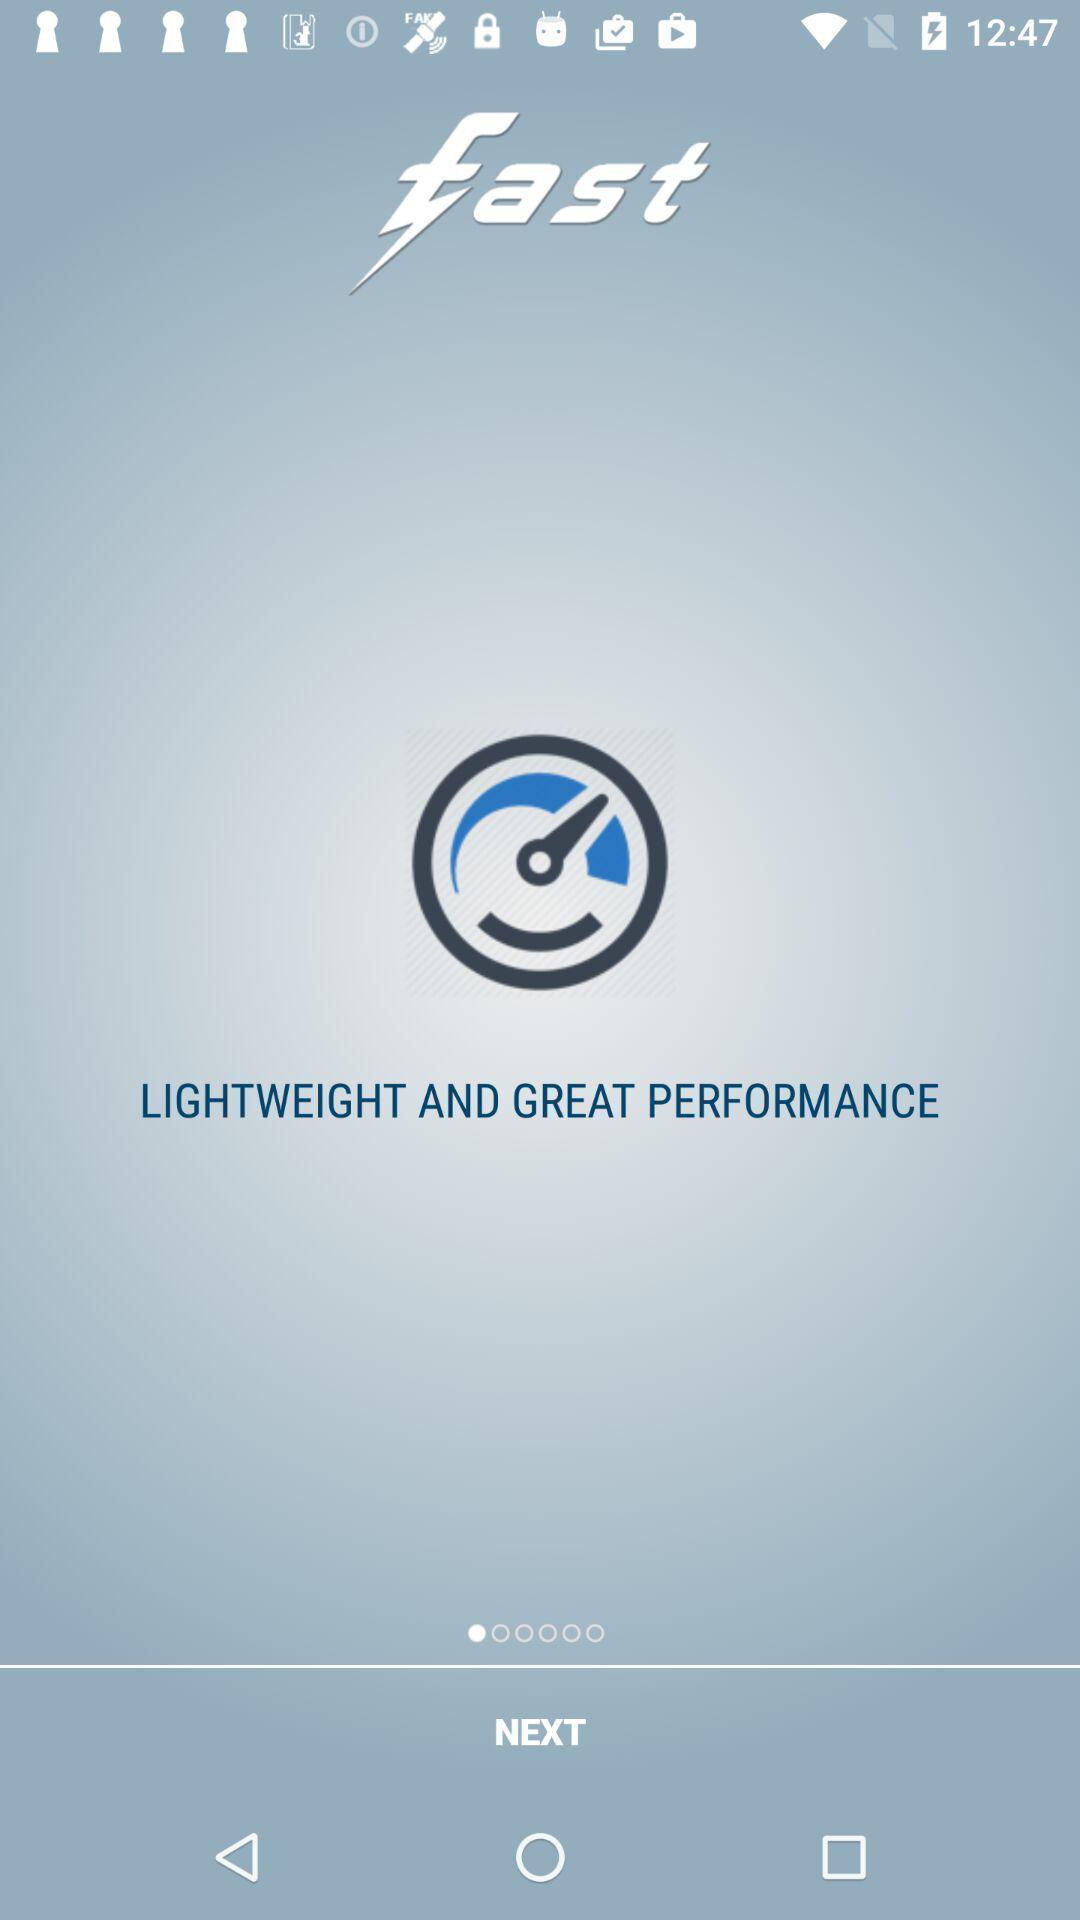What is the overall content of this screenshot? Welcome page of an internet speed test app. 